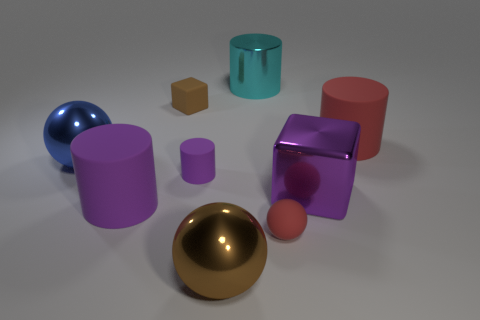Add 1 big matte things. How many objects exist? 10 Subtract all blocks. How many objects are left? 7 Add 9 small spheres. How many small spheres are left? 10 Add 6 small green rubber balls. How many small green rubber balls exist? 6 Subtract 0 yellow cylinders. How many objects are left? 9 Subtract all big brown objects. Subtract all big shiny balls. How many objects are left? 6 